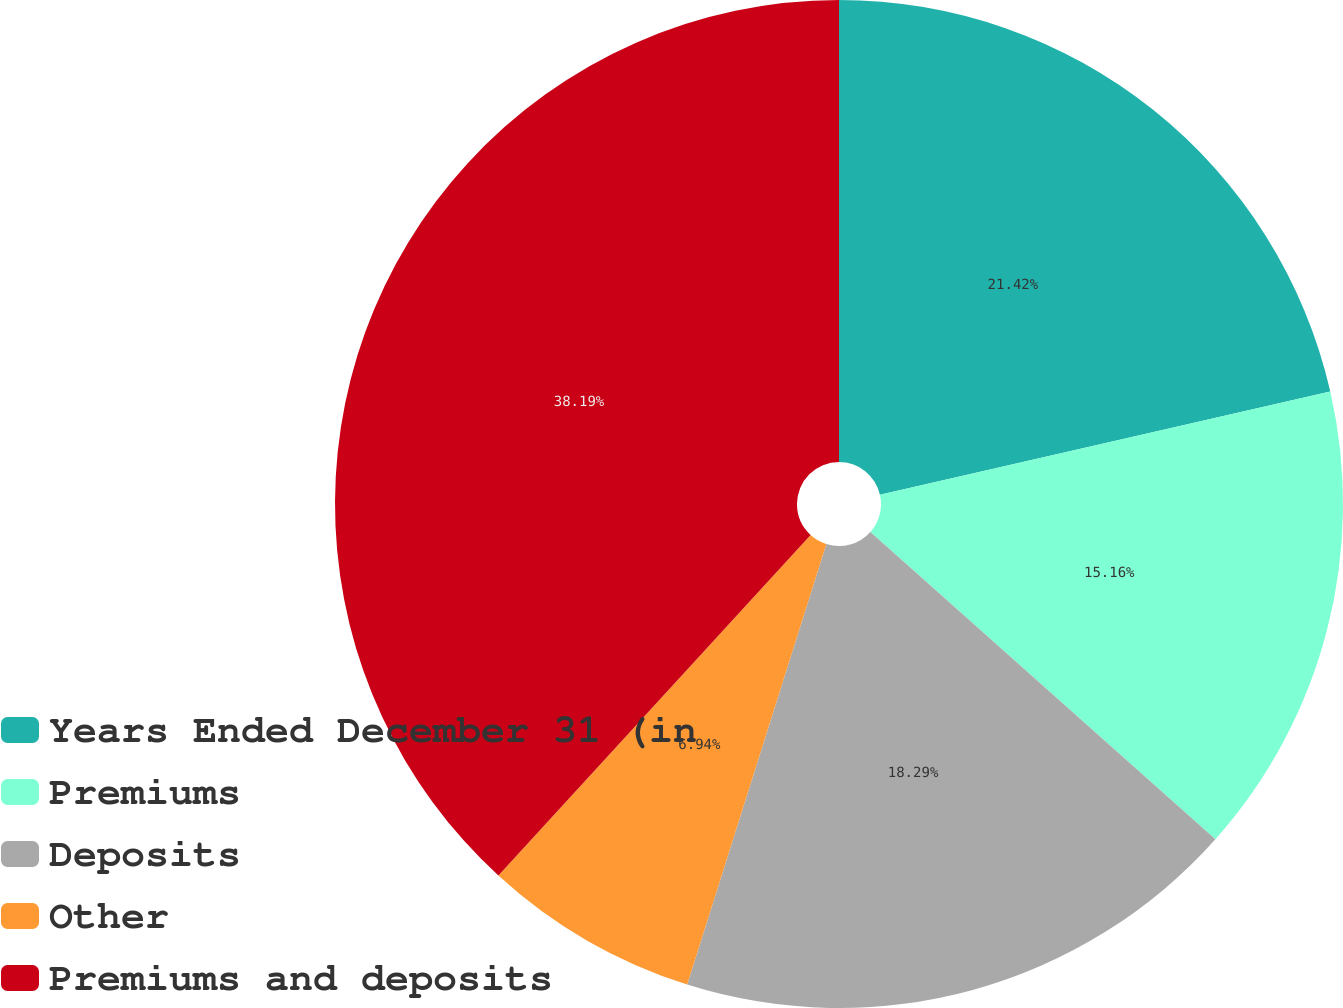Convert chart. <chart><loc_0><loc_0><loc_500><loc_500><pie_chart><fcel>Years Ended December 31 (in<fcel>Premiums<fcel>Deposits<fcel>Other<fcel>Premiums and deposits<nl><fcel>21.42%<fcel>15.16%<fcel>18.29%<fcel>6.94%<fcel>38.19%<nl></chart> 